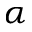Convert formula to latex. <formula><loc_0><loc_0><loc_500><loc_500>\alpha</formula> 